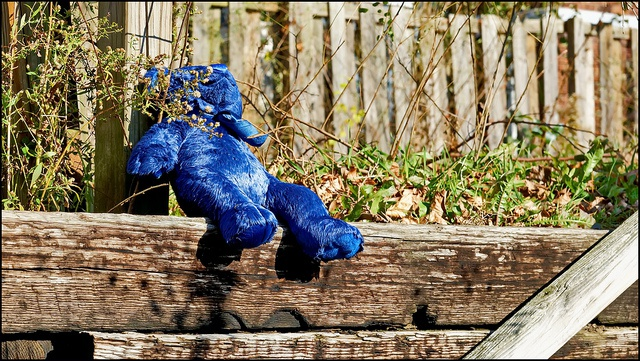Describe the objects in this image and their specific colors. I can see a teddy bear in black, navy, blue, and darkblue tones in this image. 